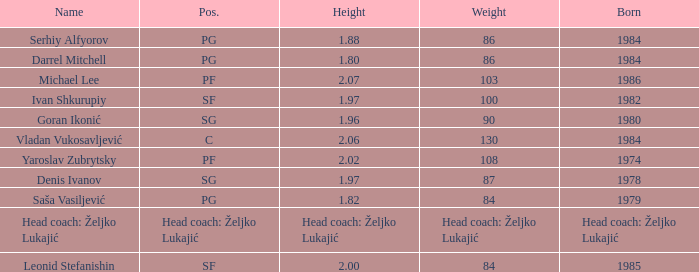Which position did Michael Lee play? PF. 